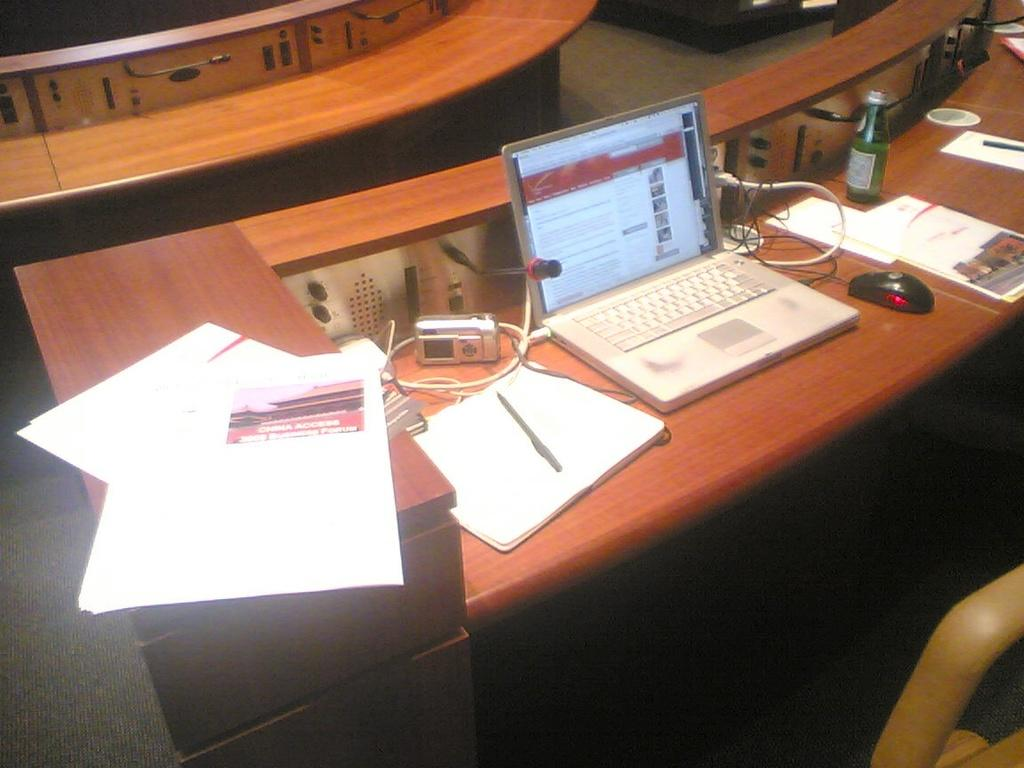What piece of furniture is in the image? There is a table in the image. What electronic device is on the table? A laptop is present on the table. What other items can be seen on the table? There is a bottle, a mouse, papers, wires, and switch boards on the table. How many tables are visible in the image? There are two tables visible in the image. What type of list can be seen on the table in the image? There is no list present on the table in the image. Is there any steam coming from the laptop in the image? There is no steam visible in the image, and the laptop does not appear to be generating any steam. 